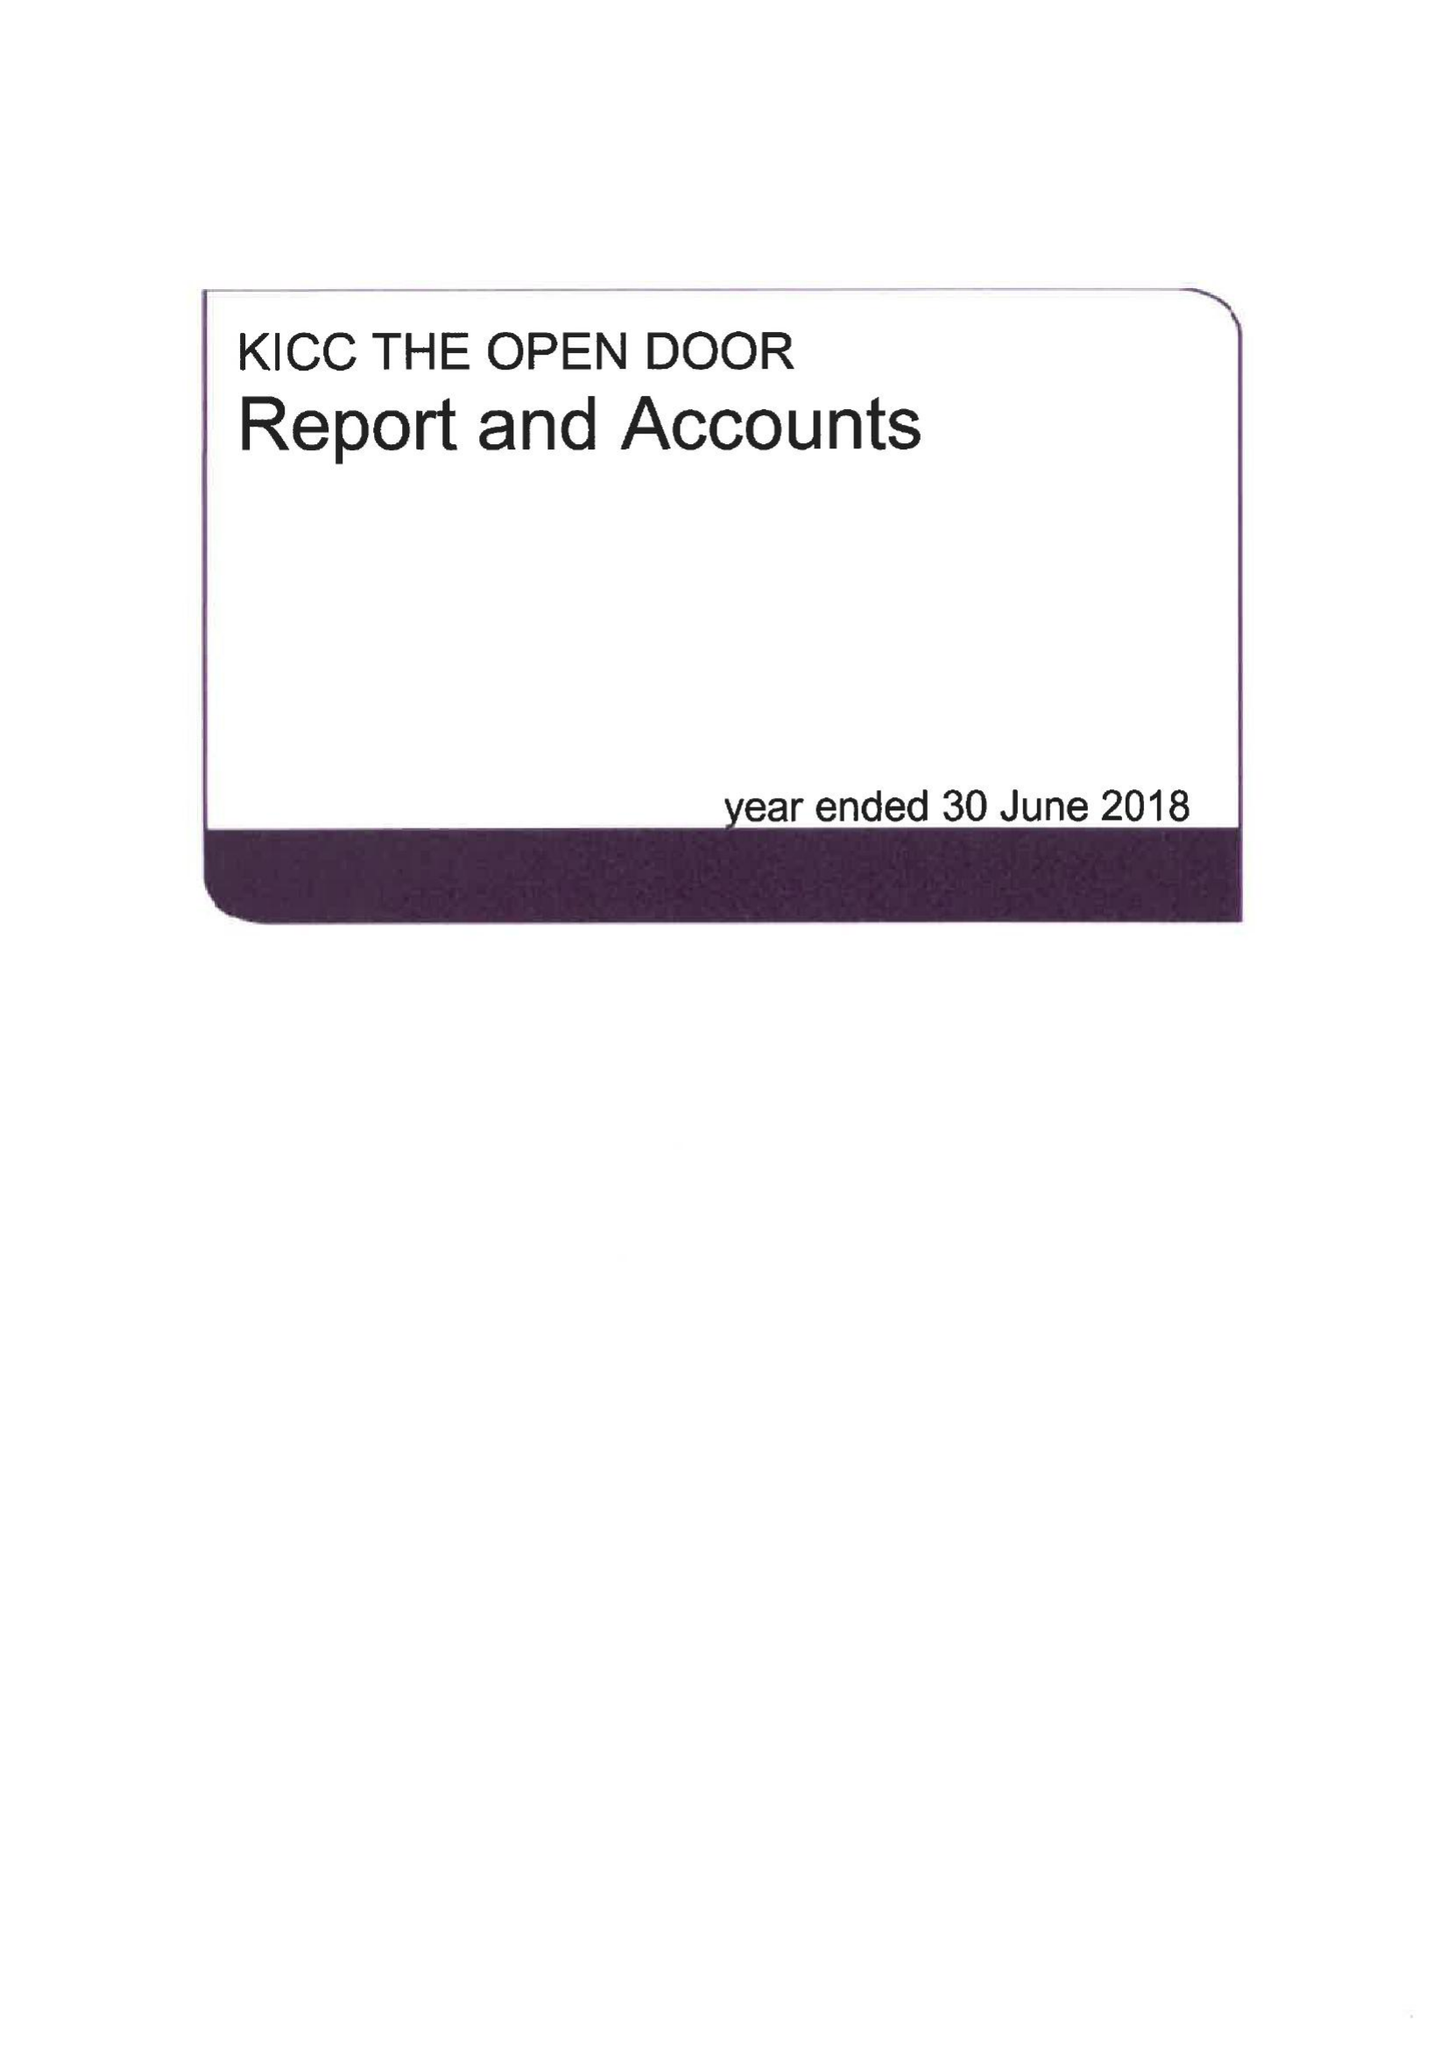What is the value for the charity_number?
Answer the question using a single word or phrase. 1142896 